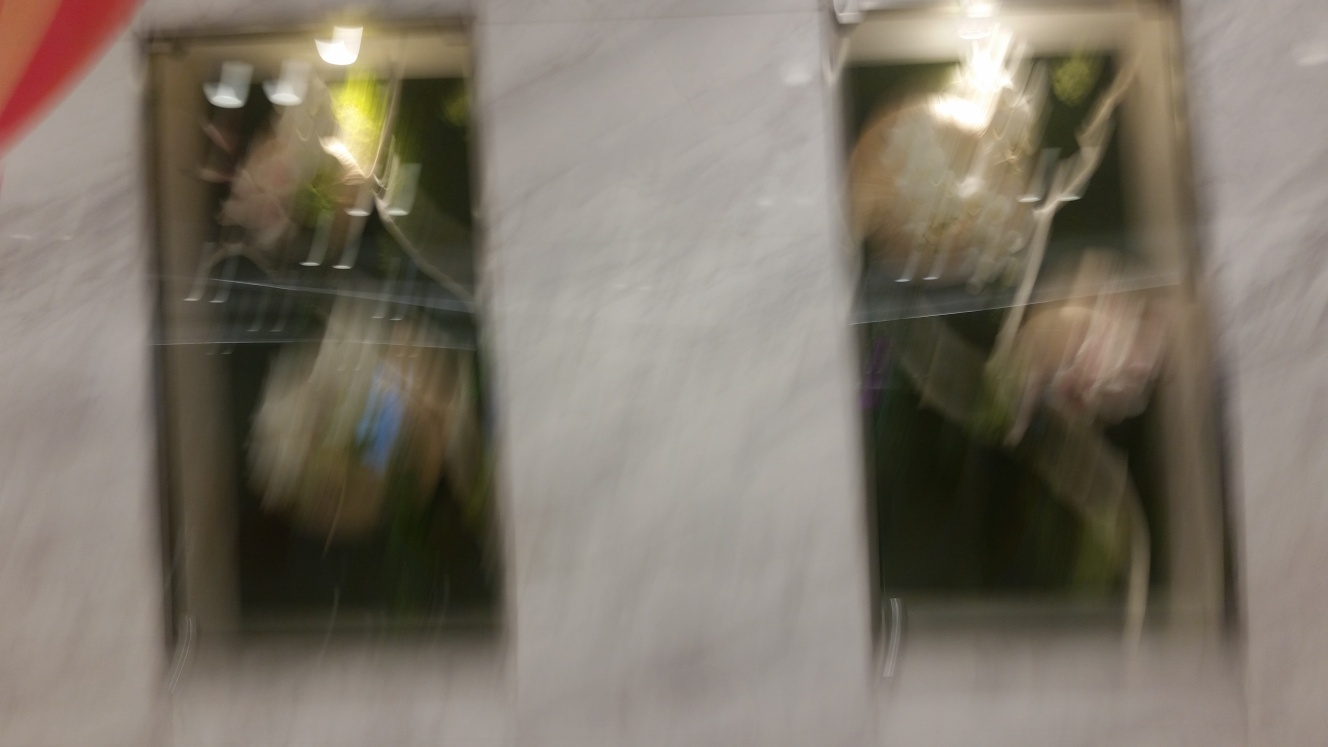What emotions does this photo evoke? This blurred photo can evoke feelings of rush and confusion, often associated with fast-paced urban life or a fleeting moment barely grasped. The lack of clear details could also stimulate the imagination, prompting viewers to interpret the image in their unique way, potentially feeling intrigue or curiosity about the obscured scene. 